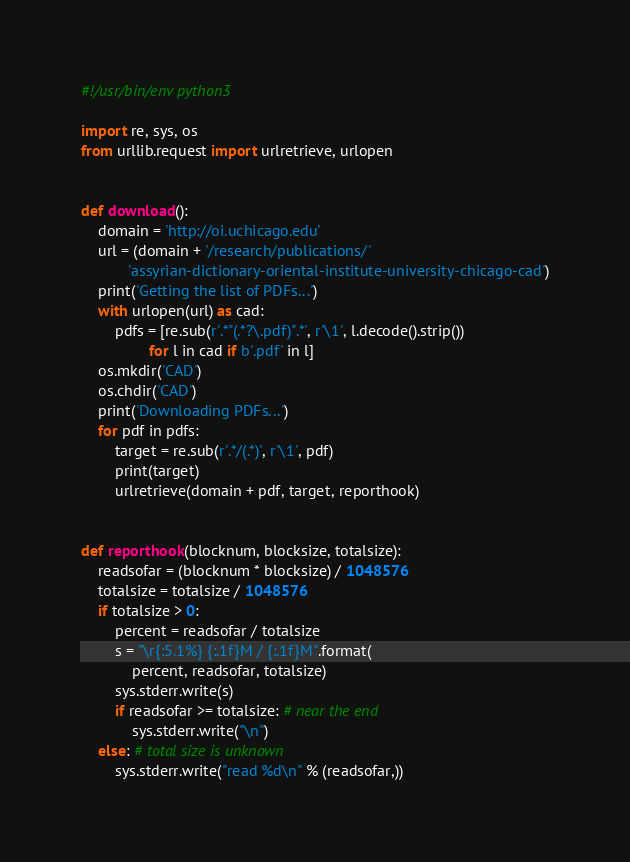Convert code to text. <code><loc_0><loc_0><loc_500><loc_500><_Python_>#!/usr/bin/env python3

import re, sys, os
from urllib.request import urlretrieve, urlopen


def download():
    domain = 'http://oi.uchicago.edu'
    url = (domain + '/research/publications/'
           'assyrian-dictionary-oriental-institute-university-chicago-cad')
    print('Getting the list of PDFs...')
    with urlopen(url) as cad:
        pdfs = [re.sub(r'.*"(.*?\.pdf)".*', r'\1', l.decode().strip())
                for l in cad if b'.pdf' in l]
    os.mkdir('CAD')
    os.chdir('CAD')
    print('Downloading PDFs...')
    for pdf in pdfs:
        target = re.sub(r'.*/(.*)', r'\1', pdf)
        print(target)
        urlretrieve(domain + pdf, target, reporthook)


def reporthook(blocknum, blocksize, totalsize):
    readsofar = (blocknum * blocksize) / 1048576
    totalsize = totalsize / 1048576
    if totalsize > 0:
        percent = readsofar / totalsize
        s = "\r{:5.1%} {:.1f}M / {:.1f}M".format(
            percent, readsofar, totalsize)
        sys.stderr.write(s)
        if readsofar >= totalsize: # near the end
            sys.stderr.write("\n")
    else: # total size is unknown
        sys.stderr.write("read %d\n" % (readsofar,))
</code> 